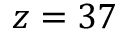<formula> <loc_0><loc_0><loc_500><loc_500>z = 3 7</formula> 